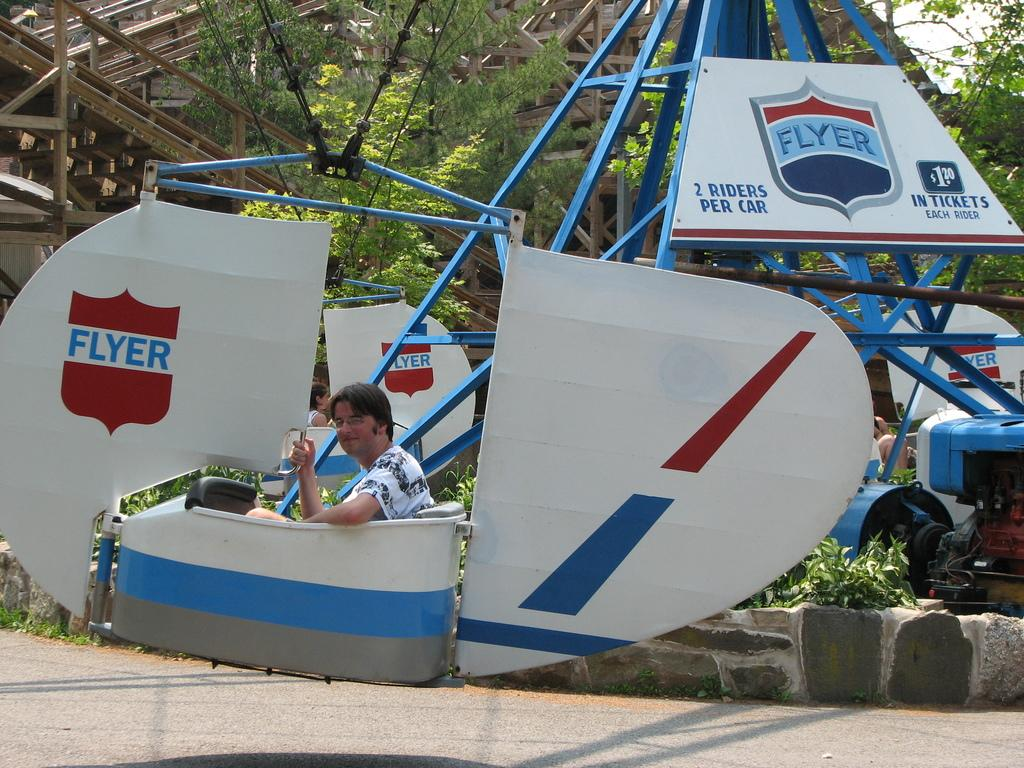<image>
Give a short and clear explanation of the subsequent image. A man is riding an amusement ride that says 2 Rides Per Car. 